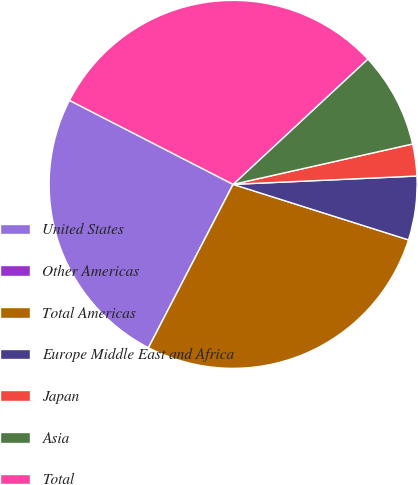Convert chart. <chart><loc_0><loc_0><loc_500><loc_500><pie_chart><fcel>United States<fcel>Other Americas<fcel>Total Americas<fcel>Europe Middle East and Africa<fcel>Japan<fcel>Asia<fcel>Total<nl><fcel>24.94%<fcel>0.0%<fcel>27.73%<fcel>5.6%<fcel>2.8%<fcel>8.4%<fcel>30.53%<nl></chart> 